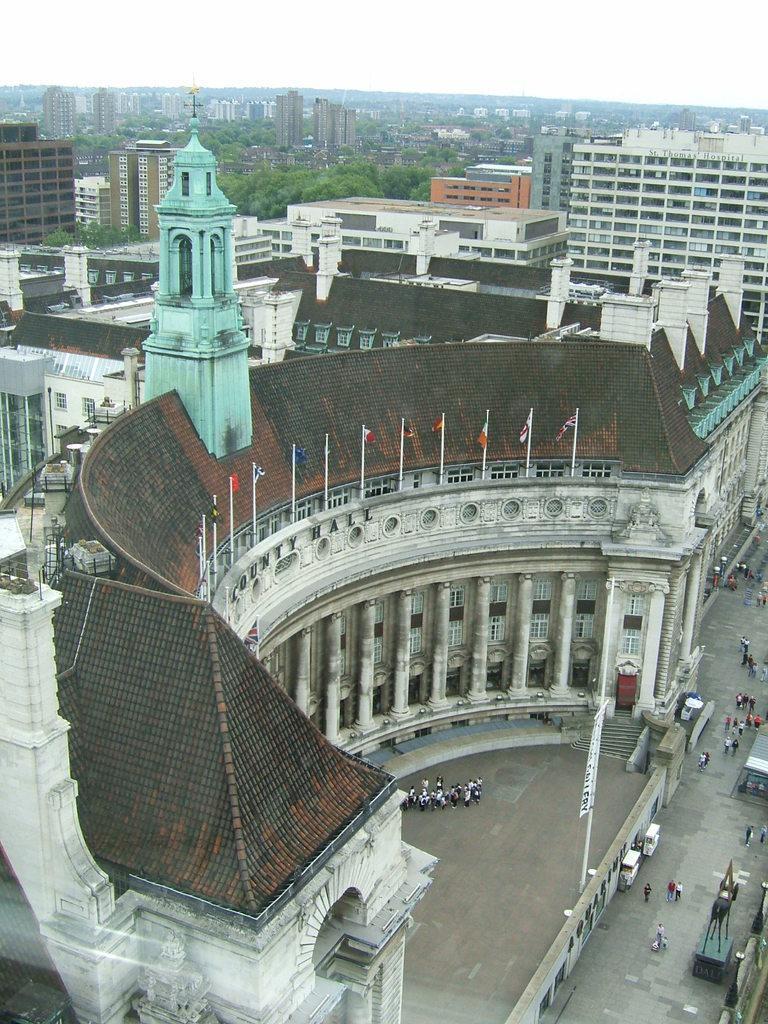Could you give a brief overview of what you see in this image? In this image we can see the aerial view of a city. In this we can see trees, buildings, tower, flags, pillars, poles and some persons on the floor. 